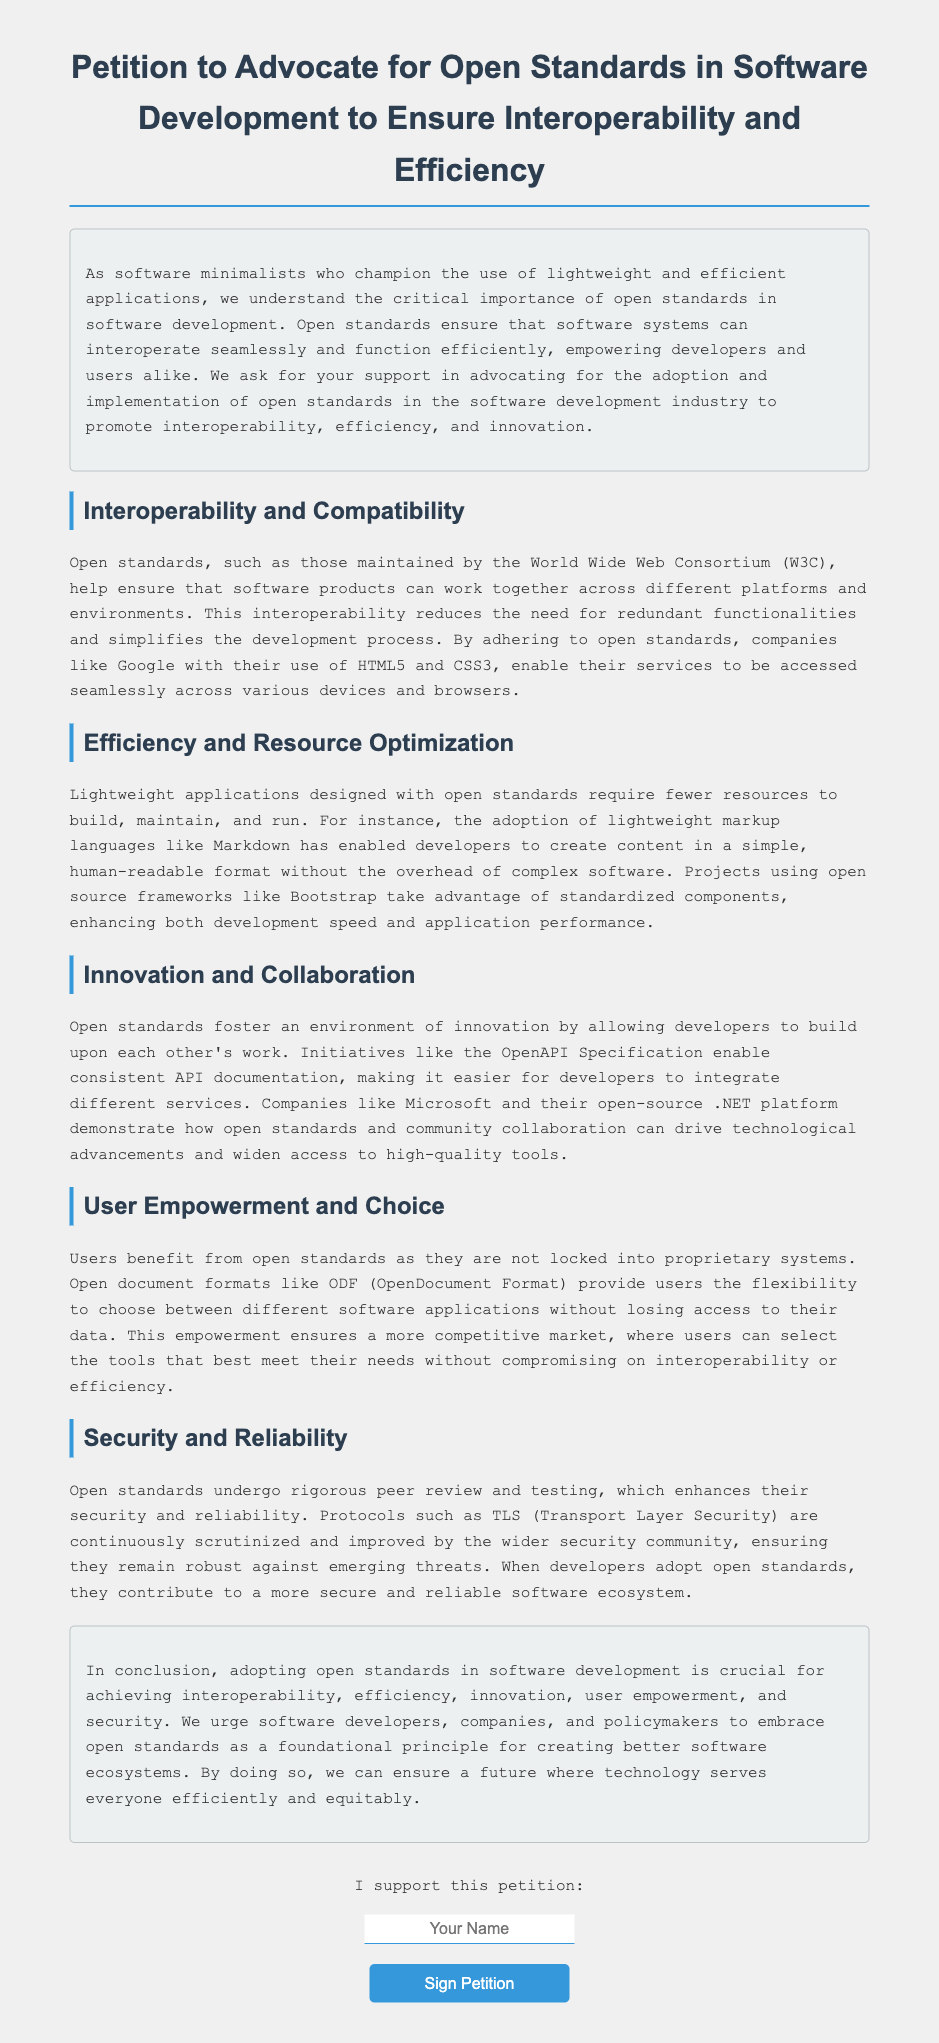What is the title of the petition? The title of the petition is explicitly stated at the top of the document.
Answer: Petition to Advocate for Open Standards in Software Development to Ensure Interoperability and Efficiency Who is mentioned as maintaining open standards? The World Wide Web Consortium is specifically cited as the maintainer of open standards in the document.
Answer: World Wide Web Consortium What does the conclusion urge? The conclusion contains a call to action that urges specific groups to embrace a certain principle in software development.
Answer: Embrace open standards What is an example of an open document format mentioned? The document refers to a specific open document format that provides user flexibility.
Answer: ODF (OpenDocument Format) Which security protocol is highlighted in the document? The document discusses a specific protocol known for its rigorous peer review process concerning security.
Answer: TLS (Transport Layer Security) What does the introduction state is critical for software minimalists? The introduction highlights an important concept that supports the philosophy of software minimalism.
Answer: Open standards How does the document describe lightweight applications? The document emphasizes a characteristic of lightweight applications that makes them advantageous for users and developers.
Answer: Require fewer resources Name one benefit of open standards mentioned in the point about User Empowerment and Choice. The document states a specific advantage of open standards that impacts user freedom.
Answer: Not locked into proprietary systems 